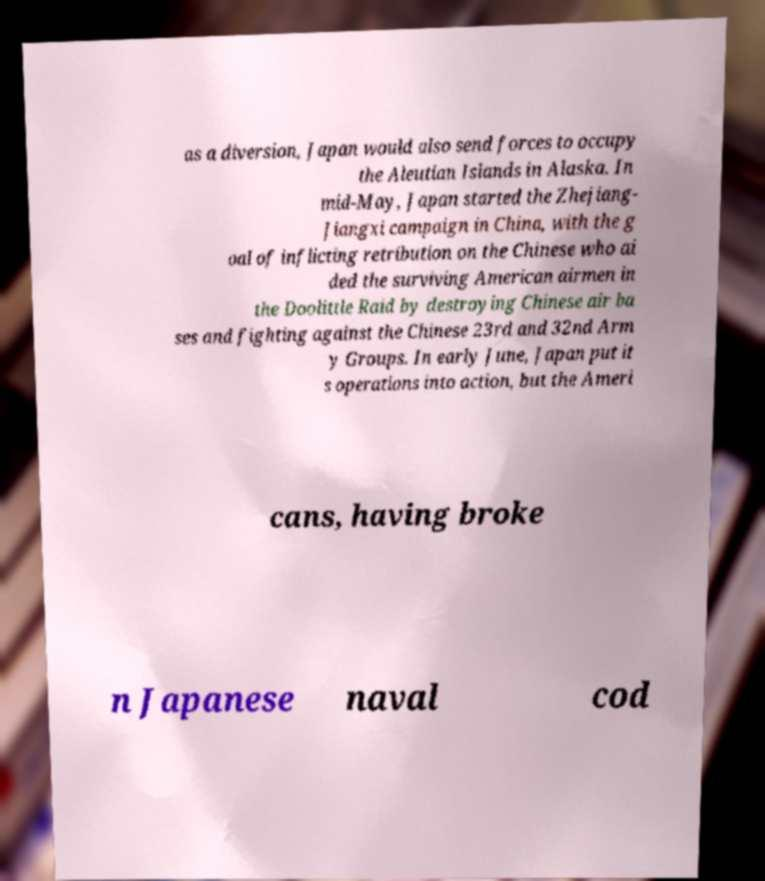There's text embedded in this image that I need extracted. Can you transcribe it verbatim? as a diversion, Japan would also send forces to occupy the Aleutian Islands in Alaska. In mid-May, Japan started the Zhejiang- Jiangxi campaign in China, with the g oal of inflicting retribution on the Chinese who ai ded the surviving American airmen in the Doolittle Raid by destroying Chinese air ba ses and fighting against the Chinese 23rd and 32nd Arm y Groups. In early June, Japan put it s operations into action, but the Ameri cans, having broke n Japanese naval cod 